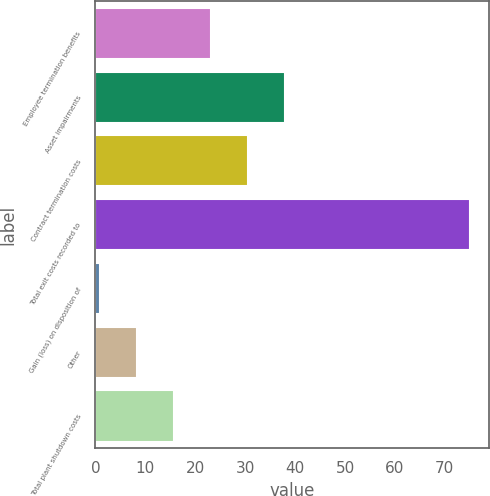Convert chart to OTSL. <chart><loc_0><loc_0><loc_500><loc_500><bar_chart><fcel>Employee termination benefits<fcel>Asset impairments<fcel>Contract termination costs<fcel>Total exit costs recorded to<fcel>Gain (loss) on disposition of<fcel>Other<fcel>Total plant shutdown costs<nl><fcel>23.2<fcel>38<fcel>30.6<fcel>75<fcel>1<fcel>8.4<fcel>15.8<nl></chart> 